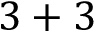Convert formula to latex. <formula><loc_0><loc_0><loc_500><loc_500>3 + 3</formula> 